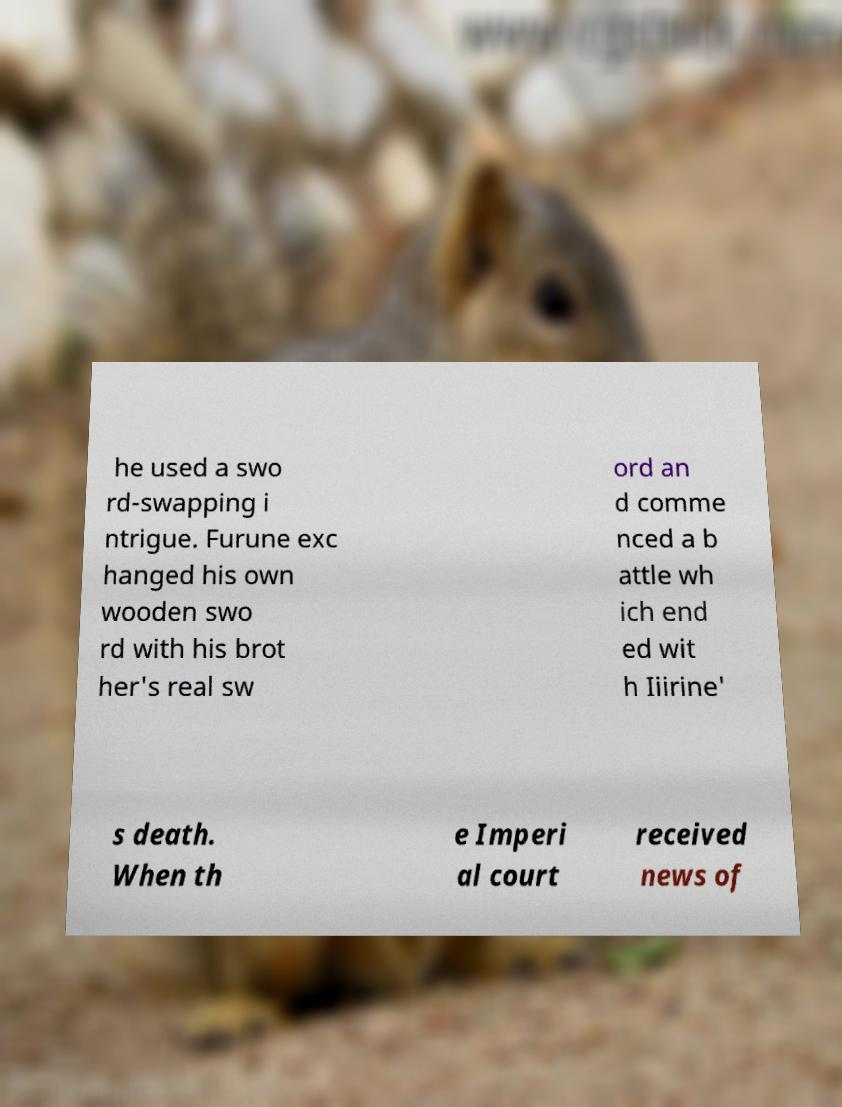Please read and relay the text visible in this image. What does it say? he used a swo rd-swapping i ntrigue. Furune exc hanged his own wooden swo rd with his brot her's real sw ord an d comme nced a b attle wh ich end ed wit h Iiirine' s death. When th e Imperi al court received news of 